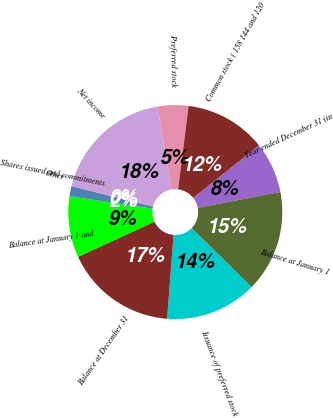<chart> <loc_0><loc_0><loc_500><loc_500><pie_chart><fcel>Year ended December 31 (in<fcel>Balance at January 1<fcel>Issuance of preferred stock<fcel>Balance at December 31<fcel>Balance at January 1 and<fcel>Shares issued and commitments<fcel>Other<fcel>Net income<fcel>Preferred stock<fcel>Common stock ( 158 144 and 120<nl><fcel>7.69%<fcel>15.38%<fcel>13.84%<fcel>16.92%<fcel>9.23%<fcel>1.54%<fcel>0.0%<fcel>18.46%<fcel>4.62%<fcel>12.31%<nl></chart> 